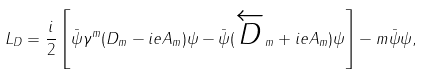Convert formula to latex. <formula><loc_0><loc_0><loc_500><loc_500>L _ { D } = \frac { i } { 2 } \left [ \bar { \psi } \gamma ^ { m } ( D _ { m } - i e A _ { m } ) \psi - \bar { \psi } ( \overleftarrow { D } _ { m } + i e A _ { m } ) \psi \right ] - m \bar { \psi } \psi ,</formula> 